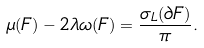<formula> <loc_0><loc_0><loc_500><loc_500>\mu ( F ) - 2 \lambda \omega ( F ) = \frac { \sigma _ { L } ( \partial F ) } { \pi } .</formula> 